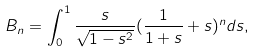<formula> <loc_0><loc_0><loc_500><loc_500>B _ { n } = \int _ { 0 } ^ { 1 } \frac { s } { \sqrt { 1 - s ^ { 2 } } } ( \frac { 1 } { 1 + s } + s ) ^ { n } d s ,</formula> 